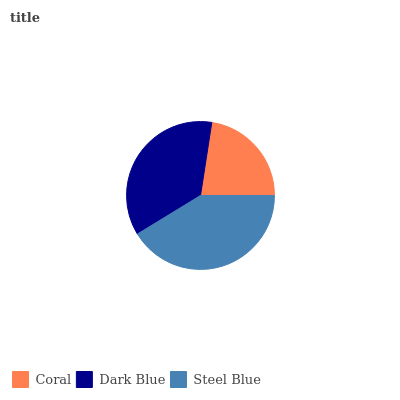Is Coral the minimum?
Answer yes or no. Yes. Is Steel Blue the maximum?
Answer yes or no. Yes. Is Dark Blue the minimum?
Answer yes or no. No. Is Dark Blue the maximum?
Answer yes or no. No. Is Dark Blue greater than Coral?
Answer yes or no. Yes. Is Coral less than Dark Blue?
Answer yes or no. Yes. Is Coral greater than Dark Blue?
Answer yes or no. No. Is Dark Blue less than Coral?
Answer yes or no. No. Is Dark Blue the high median?
Answer yes or no. Yes. Is Dark Blue the low median?
Answer yes or no. Yes. Is Coral the high median?
Answer yes or no. No. Is Steel Blue the low median?
Answer yes or no. No. 